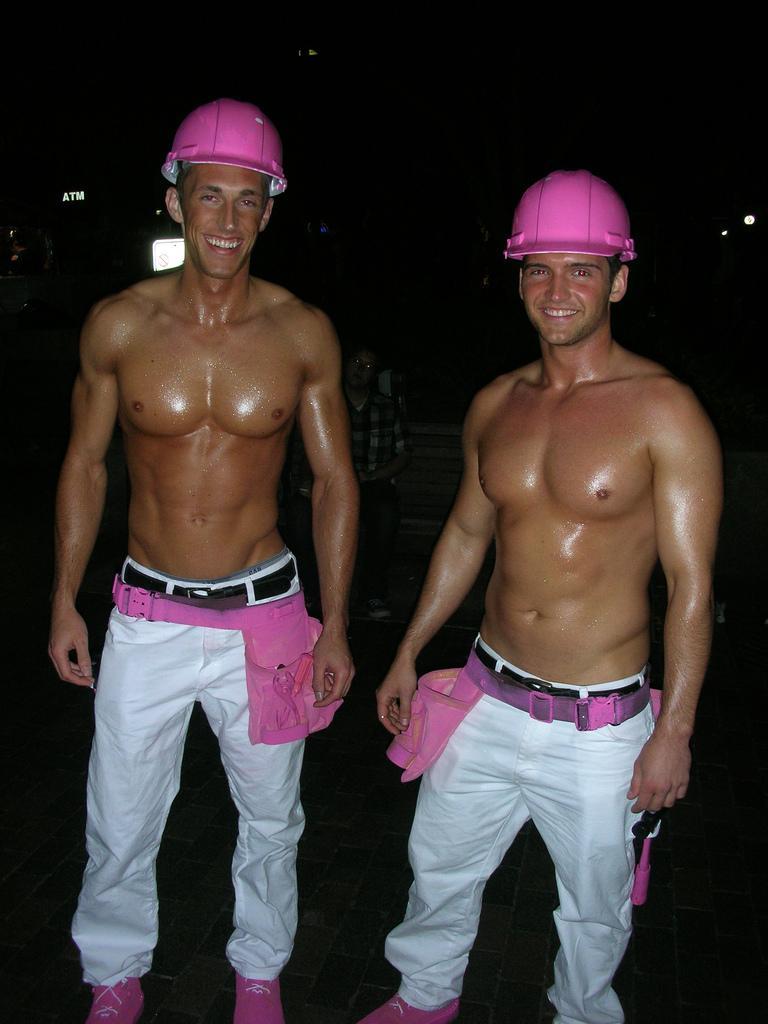Please provide a concise description of this image. In this picture I can see two persons standing and smiling, there is a person sitting, there are lights, and there is dark background. 